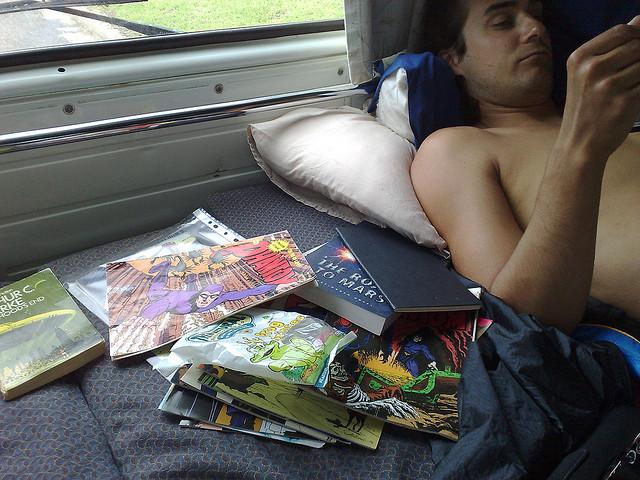Does someone in this home like golf?
Write a very short answer. No. What type of book are the majority of these?
Be succinct. Comics. Is the man going to burn all the books?
Quick response, please. No. Are those good comics?
Short answer required. Yes. 